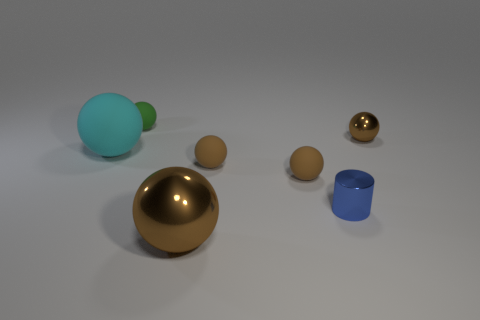Is there a large metal object that is to the left of the object that is behind the brown metal object that is to the right of the blue cylinder?
Offer a very short reply. No. What number of blue objects have the same material as the large cyan sphere?
Ensure brevity in your answer.  0. There is a shiny object that is in front of the small blue cylinder; does it have the same size as the brown shiny thing to the right of the large brown object?
Ensure brevity in your answer.  No. What is the color of the small matte sphere behind the large ball that is left of the brown metallic object in front of the big cyan matte sphere?
Your response must be concise. Green. Are there any green matte objects that have the same shape as the big brown object?
Your response must be concise. Yes. Is the number of blue cylinders that are behind the tiny blue object the same as the number of big cyan things that are in front of the big cyan matte thing?
Give a very brief answer. Yes. Is the shape of the thing on the left side of the tiny green thing the same as  the large shiny object?
Provide a short and direct response. Yes. Do the green object and the blue object have the same shape?
Keep it short and to the point. No. How many metal things are either big cyan objects or green things?
Your answer should be very brief. 0. Do the blue cylinder and the green object have the same size?
Give a very brief answer. Yes. 